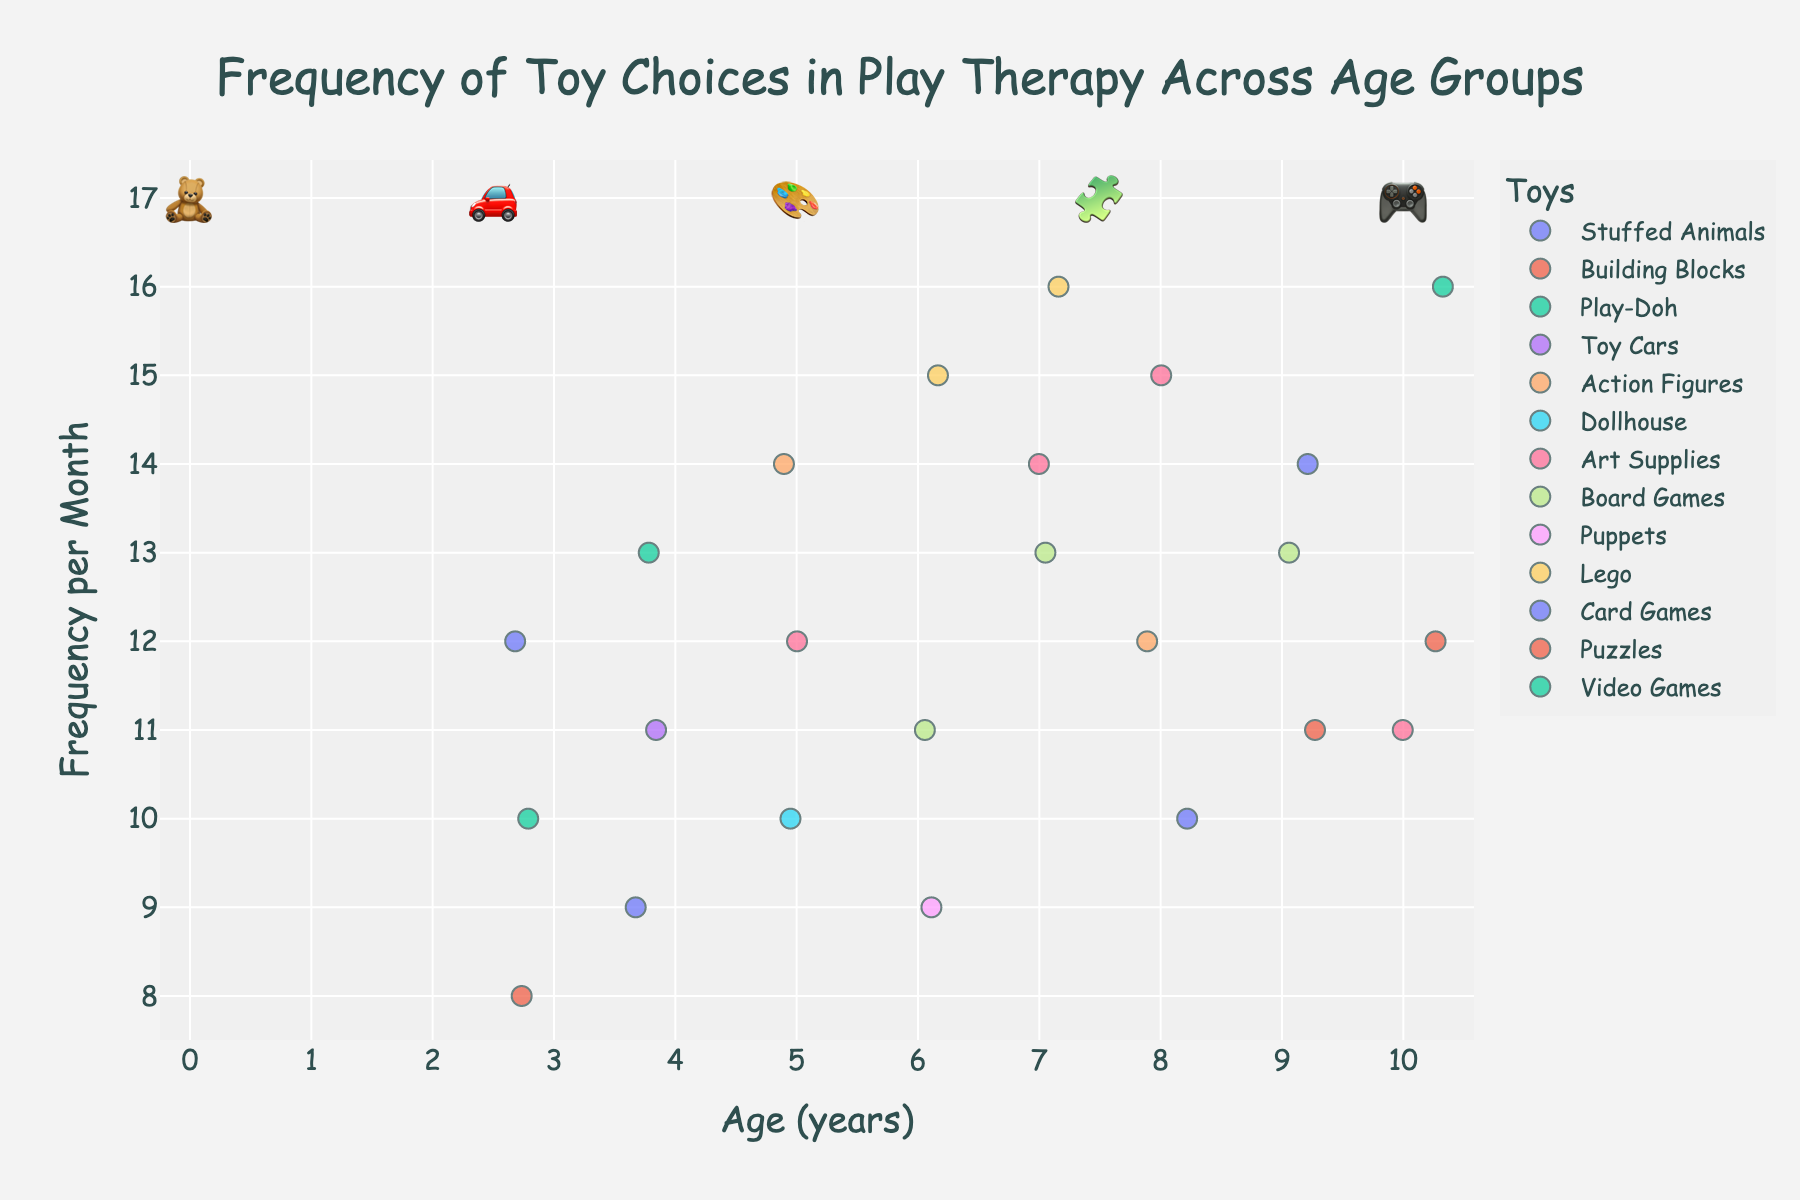What is the title of the figure? The title is usually positioned at the top of the figure and describes what the figure is about.
Answer: Frequency of Toy Choices in Play Therapy Across Age Groups What are the two axes labeled on the figure? The labels for the axes are usually positioned along the respective axes. The x-axis label is at the bottom, and the y-axis label is on the left side of the plot.
Answer: Age (years) and Frequency per Month Which toy has the highest frequency for 6-year-olds? Look at the strip plot for the age group 6 and identify the highest frequency value among the different colored points. Hover or check available legends for toy names.
Answer: Lego What is the overall trend for the frequency of Art Supplies usage as children age from 5 to 10? Observe the points corresponding to Art Supplies (same color) for ages 5, 7, 8, and 10. Note any increases or decreases in their positions along the vertical axis labeled 'Frequency per Month'.
Answer: Generally increasing with a slight drop at age 10 How does the choice of Play-Doh change from age 3 to age 4? Compare the points corresponding to Play-Doh at age 3 and age 4 in terms of their positions along the y-axis.
Answer: It increases from 10 to 13 Which age group has the highest frequency for Video Games? Identify the points for Video Games by their color and check which age group they correspond to on the x-axis.
Answer: Age 10 At what age do children choose Card Games the most frequently? Look at the points corresponding to Card Games and identify which age has the highest frequency point along the y-axis.
Answer: Age 9 What is the average frequency of Action Figures among all age groups? Identify frequencies for Action Figures across all age groups (ages 5 and 8), add them (14 and 12), and divide by the total counts (which is 2).
Answer: 13 Which toy has the smallest change in frequency between two age groups, and what is the change? Compare changes in frequency values for each toy between consecutive age groups and identify the smallest difference. E.g., compare frequencies for Stuffed Animals between age 3 and 4, etc.
Answer: Dollhouse, with a change of 0 (appears only at age 5) 